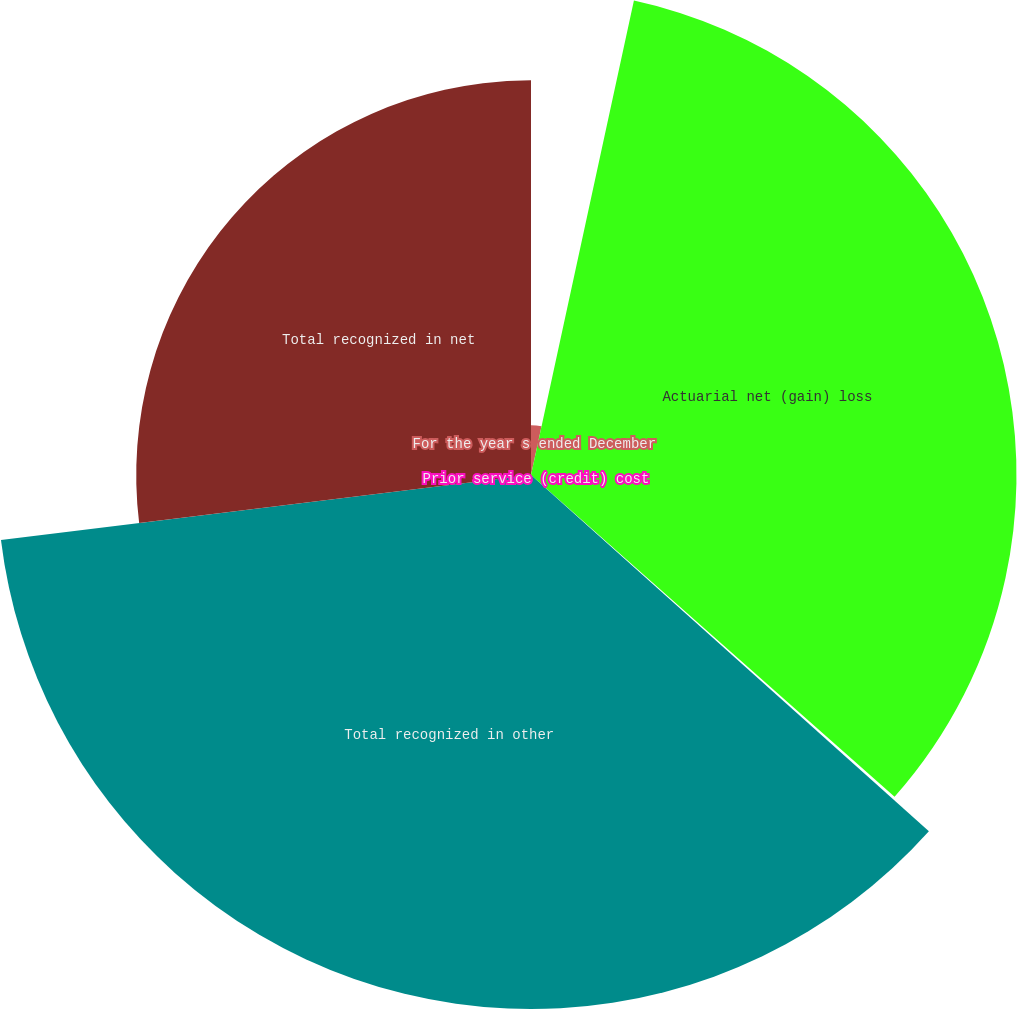<chart> <loc_0><loc_0><loc_500><loc_500><pie_chart><fcel>For the year s ended December<fcel>Actuarial net (gain) loss<fcel>Prior service (credit) cost<fcel>Total recognized in other<fcel>Total recognized in net<nl><fcel>3.4%<fcel>33.13%<fcel>0.09%<fcel>36.44%<fcel>26.94%<nl></chart> 